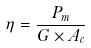<formula> <loc_0><loc_0><loc_500><loc_500>\eta = \frac { P _ { m } } { G \times A _ { c } }</formula> 